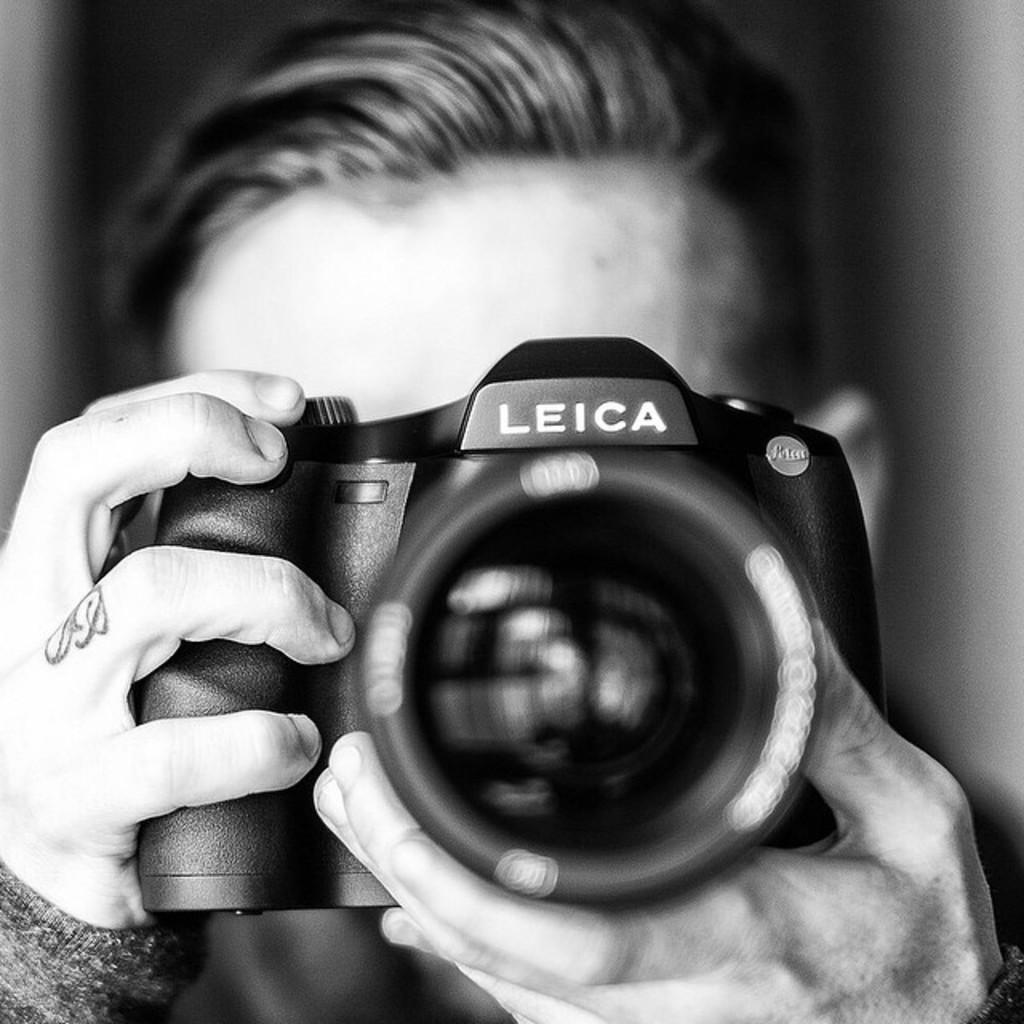Describe this image in one or two sentences. In this picture there is a man who is holding a camera. Behind him it might be a door. 